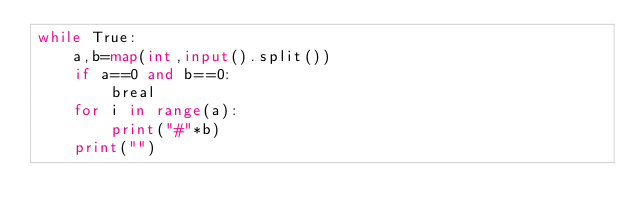Convert code to text. <code><loc_0><loc_0><loc_500><loc_500><_Python_>while True:
    a,b=map(int,input().split())
    if a==0 and b==0:
        breal
    for i in range(a):
        print("#"*b)
    print("")</code> 